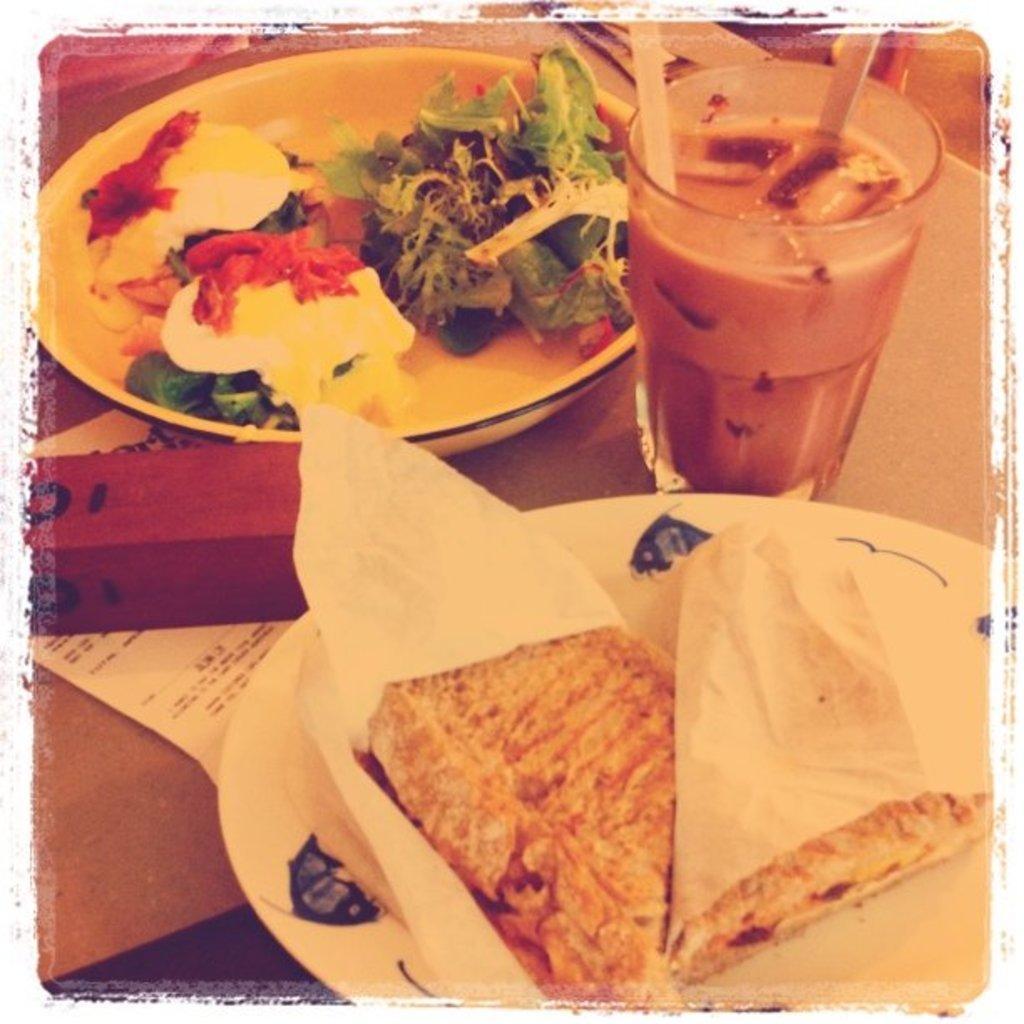Please provide a concise description of this image. In this image there is a table with two plates of food items, a glass of milkshake, a paper and an object on it. There is a sandwich and a salad on the plate. 